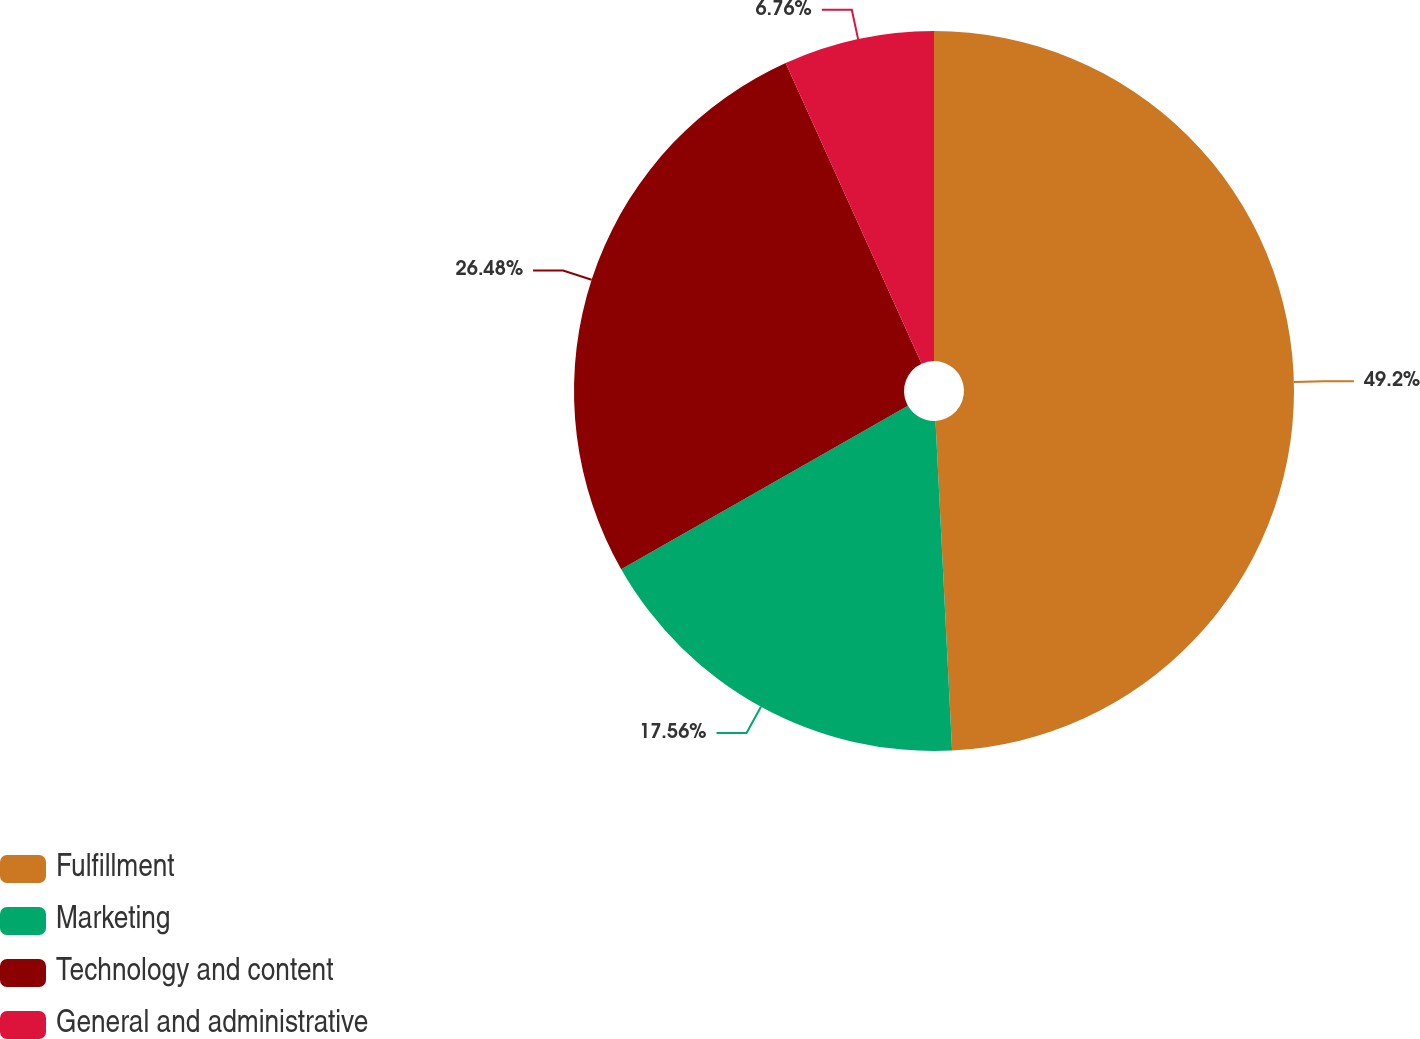<chart> <loc_0><loc_0><loc_500><loc_500><pie_chart><fcel>Fulfillment<fcel>Marketing<fcel>Technology and content<fcel>General and administrative<nl><fcel>49.2%<fcel>17.56%<fcel>26.48%<fcel>6.76%<nl></chart> 